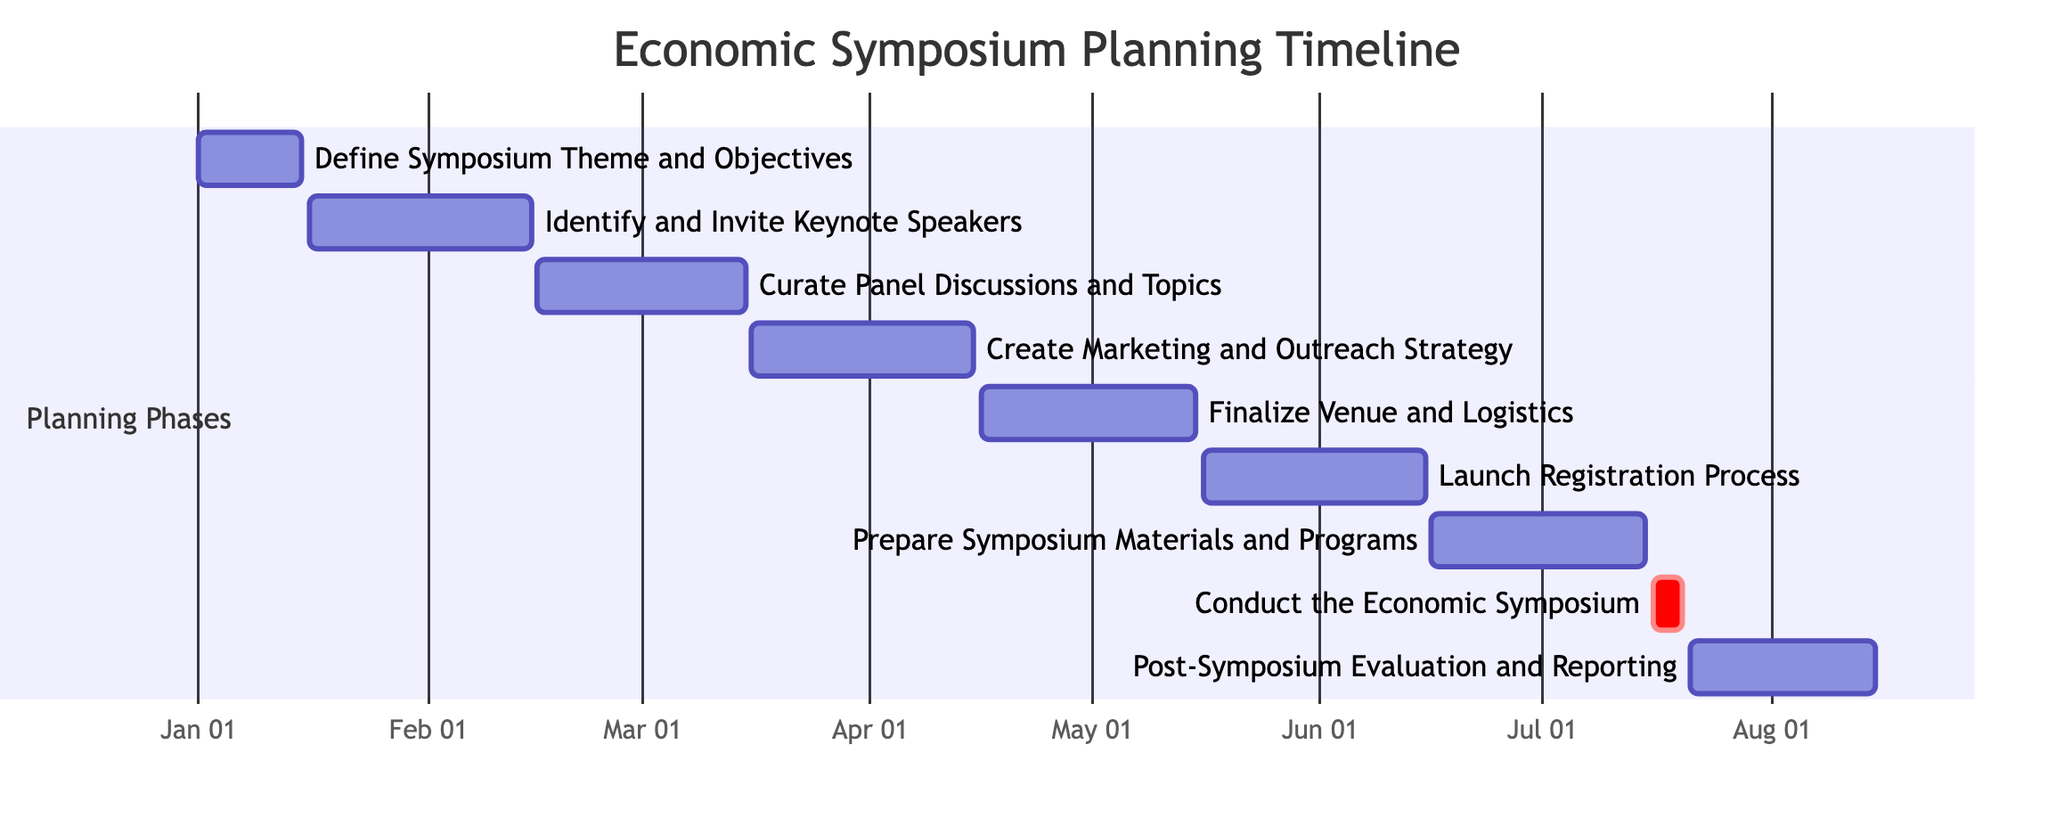What is the duration of the "Define Symposium Theme and Objectives" phase? The "Define Symposium Theme and Objectives" phase starts on January 1, 2024, and ends on January 15, 2024. To find the duration, subtract the start date from the end date, which is 15 days.
Answer: 15 days When does the "Launch Registration Process" begin? The "Launch Registration Process" phase starts on May 16, 2024. This information is directly given in the timeline of the diagram.
Answer: May 16, 2024 What comes immediately after "Curate Panel Discussions and Topics"? The phase that follows "Curate Panel Discussions and Topics," which ends on March 15, 2024, is the "Create Marketing and Outreach Strategy," starting on March 16, 2024.
Answer: Create Marketing and Outreach Strategy How many phases are there in total? By counting the distinct phases listed in the diagram, there are nine phases from "Define Symposium Theme and Objectives" to "Post-Symposium Evaluation and Reporting."
Answer: 9 What is the end date of the "Conduct the Economic Symposium"? The "Conduct the Economic Symposium" phase has an end date of July 20, 2024, as indicated in the timeline.
Answer: July 20, 2024 Which phase occurs concurrently with the "Prepare Symposium Materials and Programs"? "Prepare Symposium Materials and Programs" runs from June 16 to July 15, 2024, meaning it overlaps with "Conduct the Economic Symposium," which occurs from July 16 to July 20, 2024, directly following it.
Answer: Conduct the Economic Symposium What is the total time frame of the planning phases? The planning phases span from January 1, 2024, to August 15, 2024. By calculating the difference between these dates, we find that the overall time frame is approximately 7 months and 15 days.
Answer: 7 months and 15 days Which phase has the longest duration? "Identify and Invite Keynote Speakers" spans from January 16, 2024, to February 15, 2024, lasting 30 days, which is the longest compared to the other phases.
Answer: Identify and Invite Keynote Speakers 